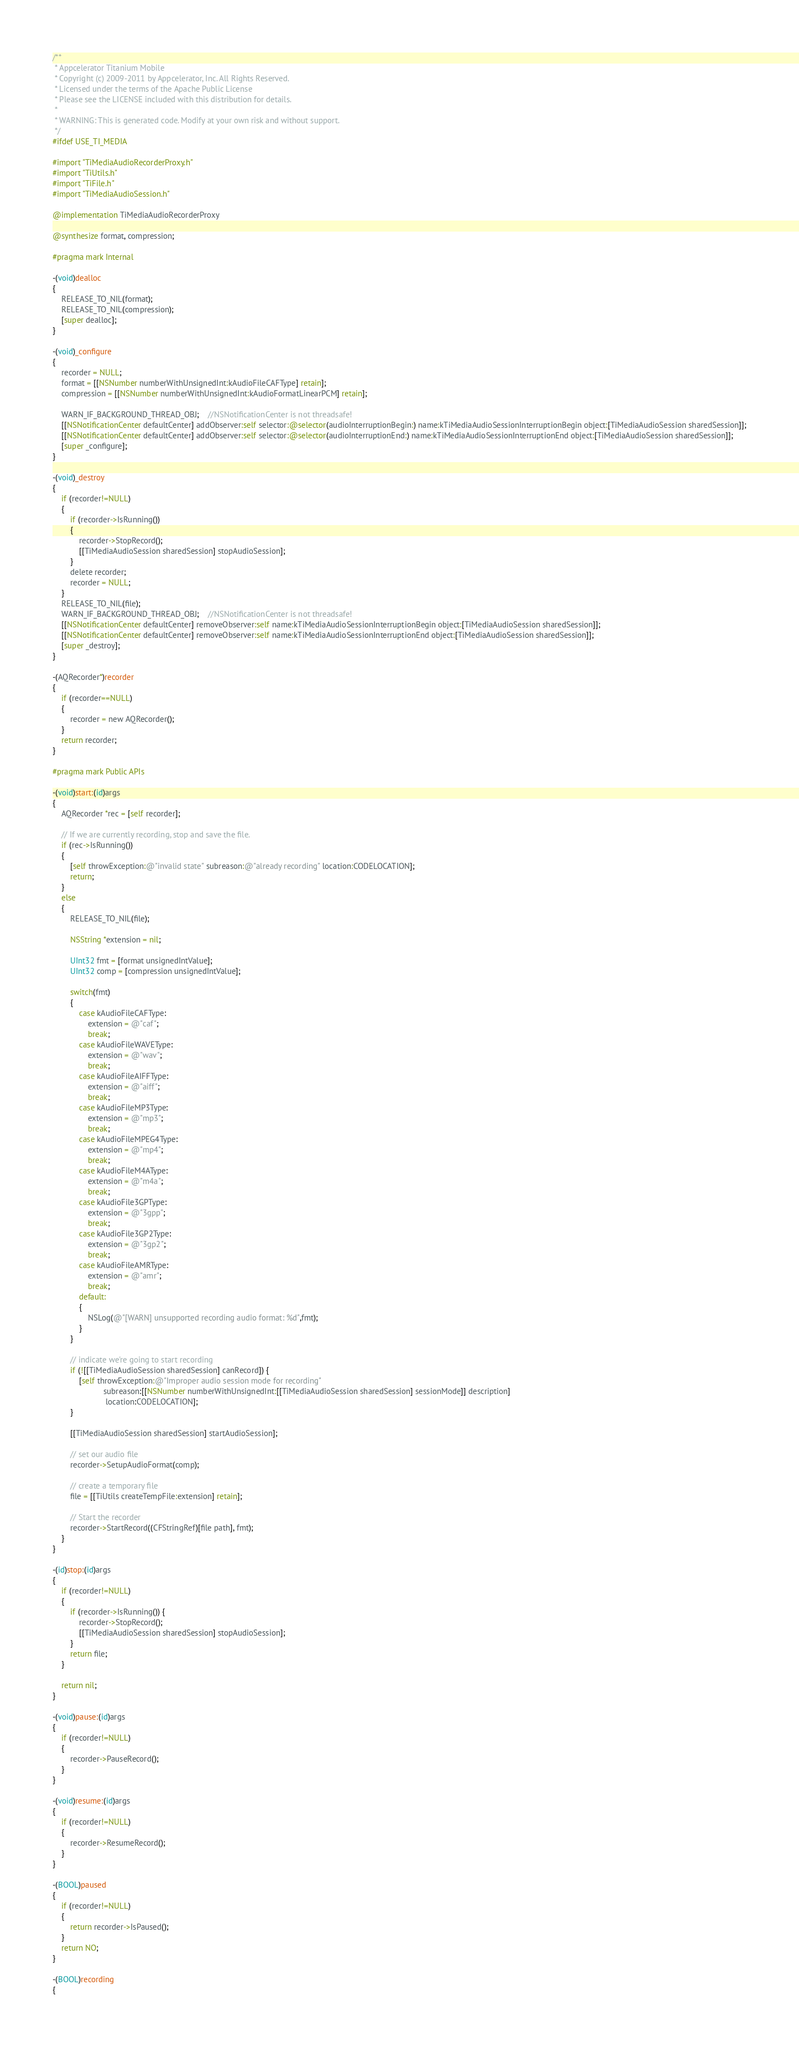<code> <loc_0><loc_0><loc_500><loc_500><_ObjectiveC_>/**
 * Appcelerator Titanium Mobile
 * Copyright (c) 2009-2011 by Appcelerator, Inc. All Rights Reserved.
 * Licensed under the terms of the Apache Public License
 * Please see the LICENSE included with this distribution for details.
 * 
 * WARNING: This is generated code. Modify at your own risk and without support.
 */
#ifdef USE_TI_MEDIA

#import "TiMediaAudioRecorderProxy.h"
#import "TiUtils.h"
#import "TiFile.h"
#import "TiMediaAudioSession.h"

@implementation TiMediaAudioRecorderProxy

@synthesize format, compression;

#pragma mark Internal 

-(void)dealloc
{
	RELEASE_TO_NIL(format);
	RELEASE_TO_NIL(compression);
	[super dealloc];
}

-(void)_configure
{
	recorder = NULL;
	format = [[NSNumber numberWithUnsignedInt:kAudioFileCAFType] retain];
	compression = [[NSNumber numberWithUnsignedInt:kAudioFormatLinearPCM] retain];
	
	WARN_IF_BACKGROUND_THREAD_OBJ;	//NSNotificationCenter is not threadsafe!
	[[NSNotificationCenter defaultCenter] addObserver:self selector:@selector(audioInterruptionBegin:) name:kTiMediaAudioSessionInterruptionBegin object:[TiMediaAudioSession sharedSession]];
	[[NSNotificationCenter defaultCenter] addObserver:self selector:@selector(audioInterruptionEnd:) name:kTiMediaAudioSessionInterruptionEnd object:[TiMediaAudioSession sharedSession]];
	[super _configure];
}

-(void)_destroy
{
	if (recorder!=NULL)
	{
		if (recorder->IsRunning())
		{
			recorder->StopRecord();
			[[TiMediaAudioSession sharedSession] stopAudioSession];
		}
		delete recorder;
		recorder = NULL;
	}
	RELEASE_TO_NIL(file);
	WARN_IF_BACKGROUND_THREAD_OBJ;	//NSNotificationCenter is not threadsafe!
	[[NSNotificationCenter defaultCenter] removeObserver:self name:kTiMediaAudioSessionInterruptionBegin object:[TiMediaAudioSession sharedSession]];
	[[NSNotificationCenter defaultCenter] removeObserver:self name:kTiMediaAudioSessionInterruptionEnd object:[TiMediaAudioSession sharedSession]];
	[super _destroy];
}

-(AQRecorder*)recorder
{
	if (recorder==NULL)
	{
		recorder = new AQRecorder();
	}
	return recorder;
}

#pragma mark Public APIs 

-(void)start:(id)args
{
	AQRecorder *rec = [self recorder];
	
	// If we are currently recording, stop and save the file.
	if (rec->IsRunning()) 
	{
		[self throwException:@"invalid state" subreason:@"already recording" location:CODELOCATION];
		return;
	}
	else
	{
		RELEASE_TO_NIL(file);
		
		NSString *extension = nil;
		
		UInt32 fmt = [format unsignedIntValue];
		UInt32 comp = [compression unsignedIntValue];
		
		switch(fmt)
		{
			case kAudioFileCAFType:
				extension = @"caf";
				break;
			case kAudioFileWAVEType:
				extension = @"wav";
				break;
			case kAudioFileAIFFType:
				extension = @"aiff";
				break;
			case kAudioFileMP3Type:
				extension = @"mp3";
				break;
			case kAudioFileMPEG4Type:
				extension = @"mp4";
				break;
			case kAudioFileM4AType:
				extension = @"m4a";
				break;
			case kAudioFile3GPType:
				extension = @"3gpp";
				break;
			case kAudioFile3GP2Type:
				extension = @"3gp2";
				break;
			case kAudioFileAMRType:
				extension = @"amr";
				break;
			default:
			{
				NSLog(@"[WARN] unsupported recording audio format: %d",fmt);
			}
		}
		
		// indicate we're going to start recording
		if (![[TiMediaAudioSession sharedSession] canRecord]) {
			[self throwException:@"Improper audio session mode for recording"
					   subreason:[[NSNumber numberWithUnsignedInt:[[TiMediaAudioSession sharedSession] sessionMode]] description]
						location:CODELOCATION];
		}
		
		[[TiMediaAudioSession sharedSession] startAudioSession];
		
		// set our audio file
		recorder->SetupAudioFormat(comp);
		
		// create a temporary file
		file = [[TiUtils createTempFile:extension] retain];
		
		// Start the recorder
		recorder->StartRecord((CFStringRef)[file path], fmt);
	}
}

-(id)stop:(id)args
{
	if (recorder!=NULL)
	{
		if (recorder->IsRunning()) {
			recorder->StopRecord();
			[[TiMediaAudioSession sharedSession] stopAudioSession];
		}
		return file;
	}
	
	return nil;
}

-(void)pause:(id)args
{
	if (recorder!=NULL)
	{
		recorder->PauseRecord();
	}
}

-(void)resume:(id)args
{
	if (recorder!=NULL)
	{
		recorder->ResumeRecord();
	}
}

-(BOOL)paused
{
	if (recorder!=NULL)
	{
		return recorder->IsPaused();
	}
	return NO;
}

-(BOOL)recording
{</code> 